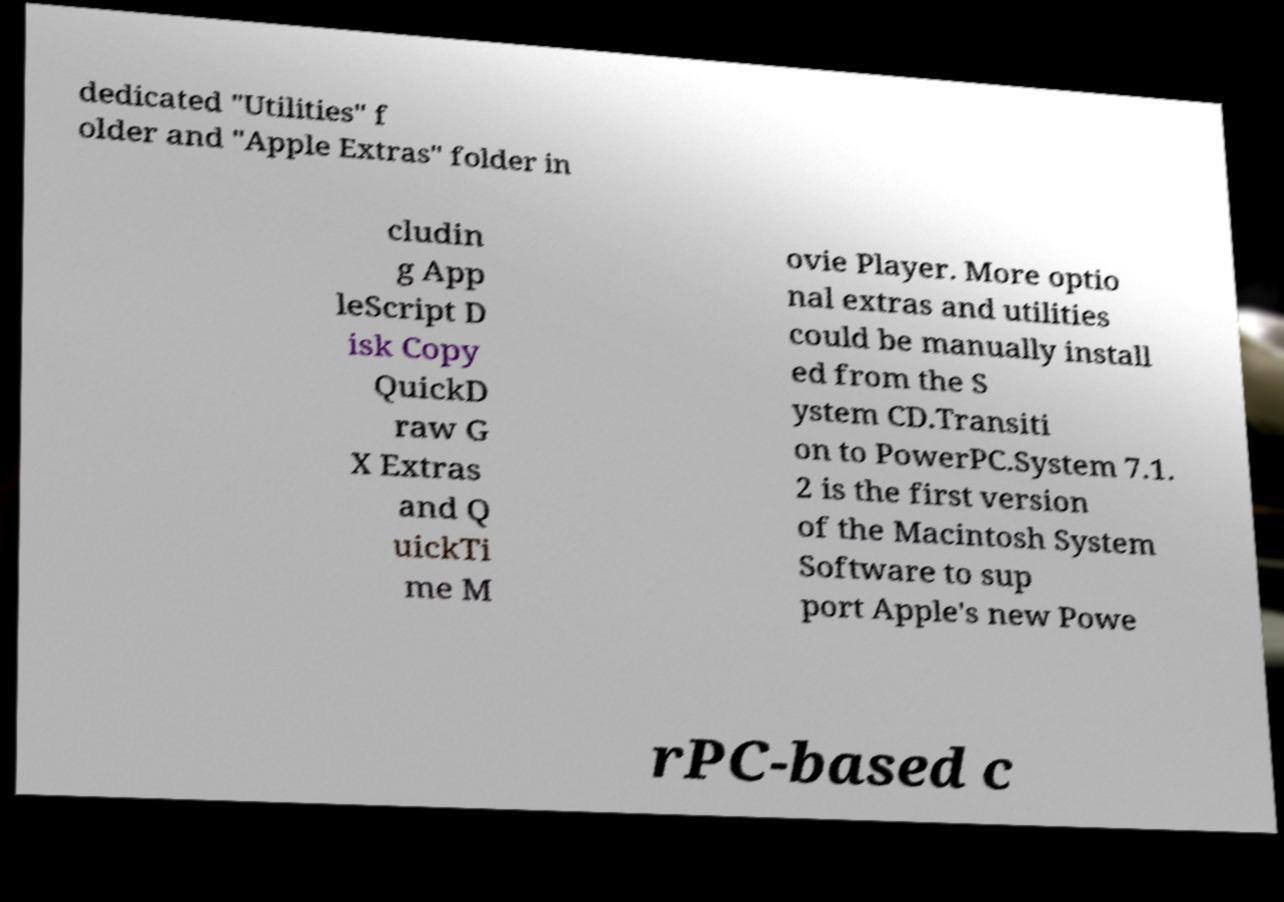I need the written content from this picture converted into text. Can you do that? dedicated "Utilities" f older and "Apple Extras" folder in cludin g App leScript D isk Copy QuickD raw G X Extras and Q uickTi me M ovie Player. More optio nal extras and utilities could be manually install ed from the S ystem CD.Transiti on to PowerPC.System 7.1. 2 is the first version of the Macintosh System Software to sup port Apple's new Powe rPC-based c 